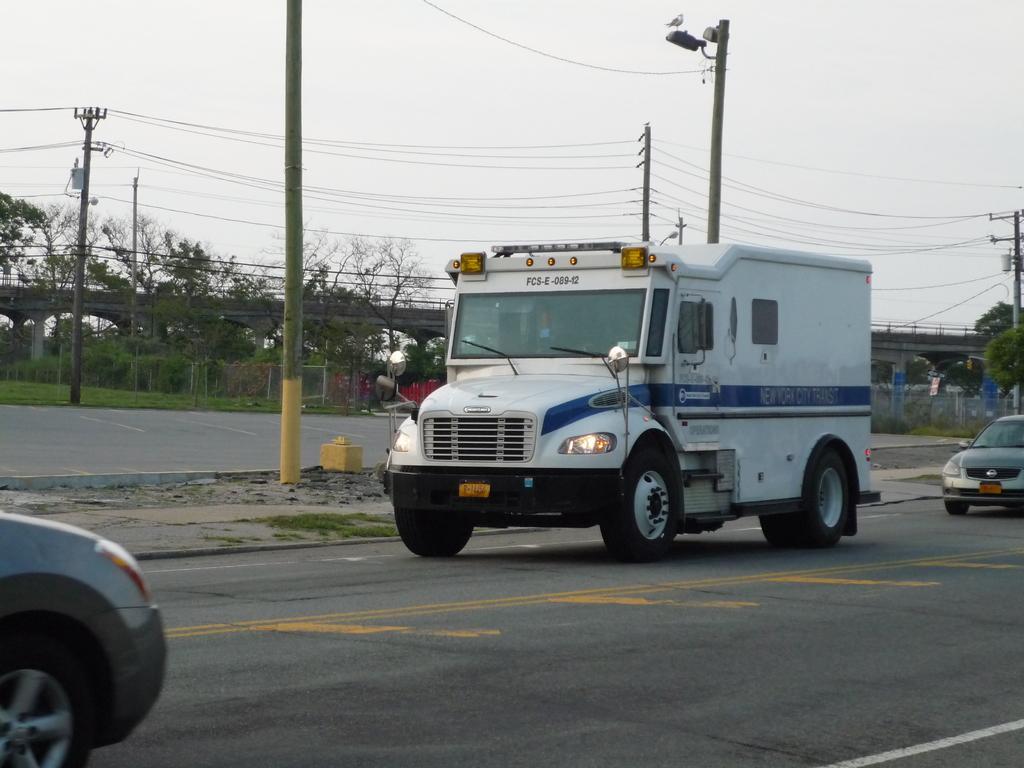Could you give a brief overview of what you see in this image? In the foreground of the picture there are vehicles on the road. In the center of the picture there are current polls, cables, grass, road and other objects. In the background there are trees, bridge, fencing, plants, grass, cables and poles. Sky is cloudy. 